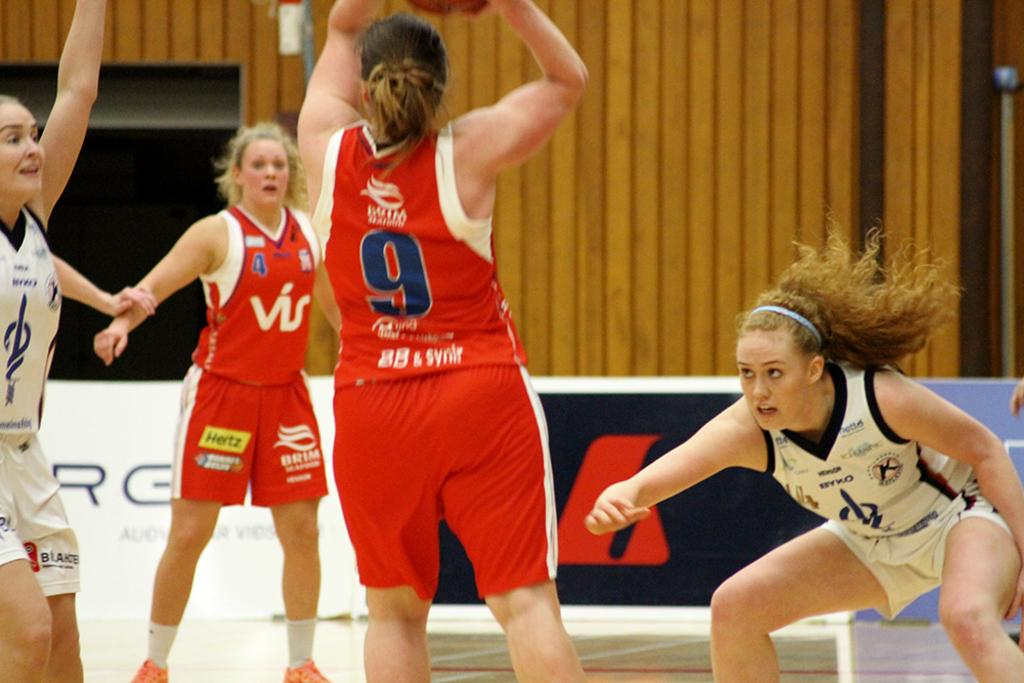<image>
Create a compact narrative representing the image presented. A girls basketball game is intense, as number 9 goes for the basket. 